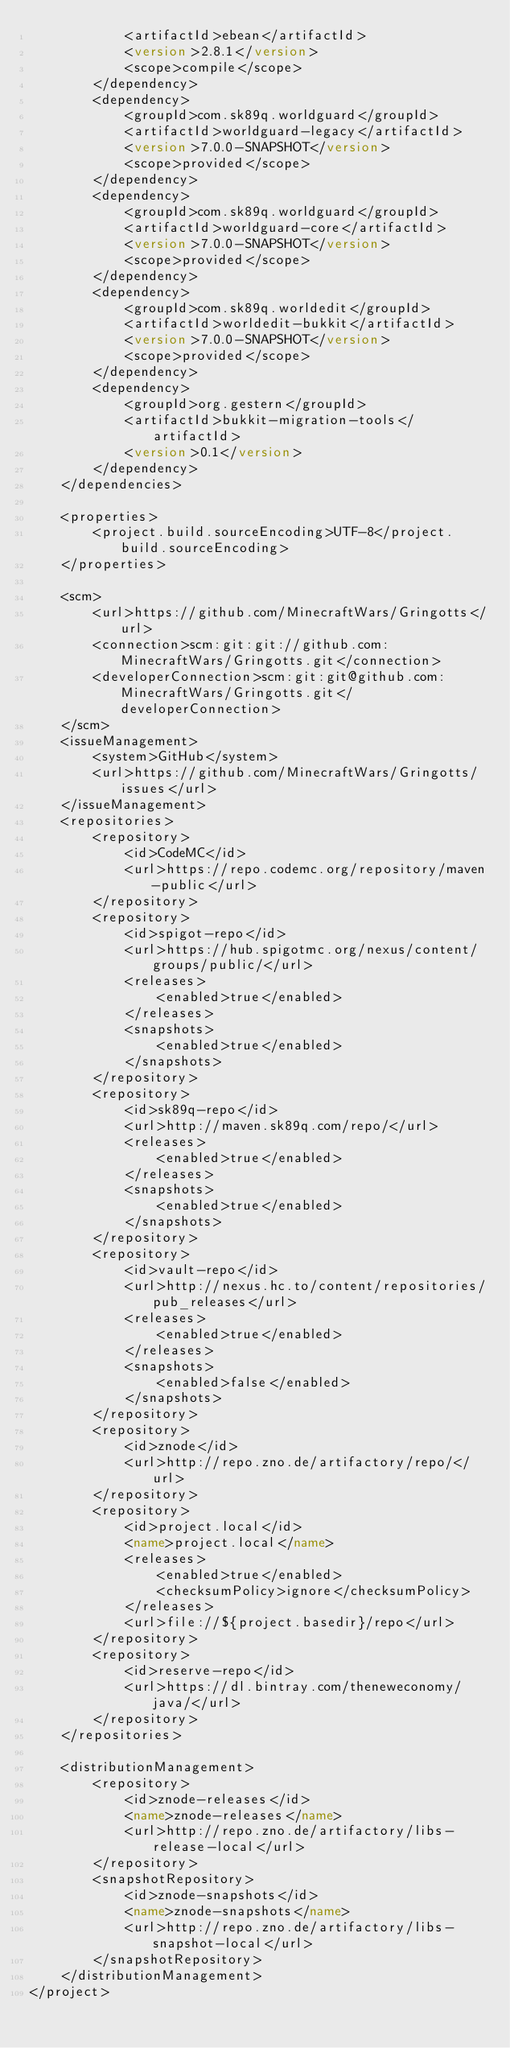<code> <loc_0><loc_0><loc_500><loc_500><_XML_>            <artifactId>ebean</artifactId>
            <version>2.8.1</version>
            <scope>compile</scope>
        </dependency>
        <dependency>
            <groupId>com.sk89q.worldguard</groupId>
            <artifactId>worldguard-legacy</artifactId>
            <version>7.0.0-SNAPSHOT</version>
            <scope>provided</scope>
        </dependency>
        <dependency>
            <groupId>com.sk89q.worldguard</groupId>
            <artifactId>worldguard-core</artifactId>
            <version>7.0.0-SNAPSHOT</version>
            <scope>provided</scope>
        </dependency>
        <dependency>
            <groupId>com.sk89q.worldedit</groupId>
            <artifactId>worldedit-bukkit</artifactId>
            <version>7.0.0-SNAPSHOT</version>
            <scope>provided</scope>
        </dependency>
        <dependency>
            <groupId>org.gestern</groupId>
            <artifactId>bukkit-migration-tools</artifactId>
            <version>0.1</version>
        </dependency>
    </dependencies>

    <properties>
        <project.build.sourceEncoding>UTF-8</project.build.sourceEncoding>
    </properties>

    <scm>
        <url>https://github.com/MinecraftWars/Gringotts</url>
        <connection>scm:git:git://github.com:MinecraftWars/Gringotts.git</connection>
        <developerConnection>scm:git:git@github.com:MinecraftWars/Gringotts.git</developerConnection>
    </scm>
    <issueManagement>
        <system>GitHub</system>
        <url>https://github.com/MinecraftWars/Gringotts/issues</url>
    </issueManagement>
    <repositories>
        <repository>
            <id>CodeMC</id>
            <url>https://repo.codemc.org/repository/maven-public</url>
        </repository>
        <repository>
            <id>spigot-repo</id>
            <url>https://hub.spigotmc.org/nexus/content/groups/public/</url>
            <releases>
                <enabled>true</enabled>
            </releases>
            <snapshots>
                <enabled>true</enabled>
            </snapshots>
        </repository>
        <repository>
            <id>sk89q-repo</id>
            <url>http://maven.sk89q.com/repo/</url>
            <releases>
                <enabled>true</enabled>
            </releases>
            <snapshots>
                <enabled>true</enabled>
            </snapshots>
        </repository>
        <repository>
            <id>vault-repo</id>
            <url>http://nexus.hc.to/content/repositories/pub_releases</url>
            <releases>
                <enabled>true</enabled>
            </releases>
            <snapshots>
                <enabled>false</enabled>
            </snapshots>
        </repository>
        <repository>
            <id>znode</id>
            <url>http://repo.zno.de/artifactory/repo/</url>
        </repository>
        <repository>
            <id>project.local</id>
            <name>project.local</name>
            <releases>
                <enabled>true</enabled>
                <checksumPolicy>ignore</checksumPolicy>
            </releases>
            <url>file://${project.basedir}/repo</url>
        </repository>
        <repository>
            <id>reserve-repo</id>
            <url>https://dl.bintray.com/theneweconomy/java/</url>
        </repository>
    </repositories>

    <distributionManagement>
        <repository>
            <id>znode-releases</id>
            <name>znode-releases</name>
            <url>http://repo.zno.de/artifactory/libs-release-local</url>
        </repository>
        <snapshotRepository>
            <id>znode-snapshots</id>
            <name>znode-snapshots</name>
            <url>http://repo.zno.de/artifactory/libs-snapshot-local</url>
        </snapshotRepository>
    </distributionManagement>
</project>
</code> 